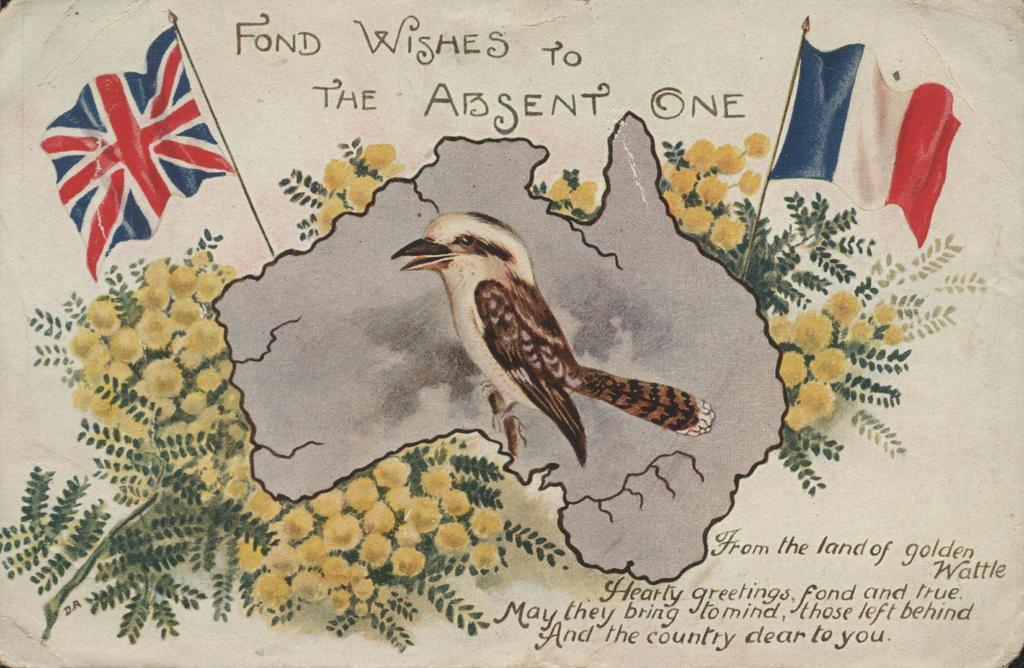What is the main subject of the art piece in the image? There is an art piece of a bird in the image. What other objects can be seen in the image besides the art piece? There are flags and flowers in the image. Is there any text present in the image? Yes, there is text in the image. How many pies are displayed on the table in the image? There is no table or pies present in the image; it features an art piece of a bird, flags, flowers, and text. 